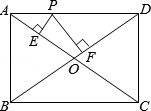As shown in the figure, the diagonals AC and BD of rectangle ABCD intersect at point O. Point P is a moving point on side AD. From point P, perpendicular PE is drawn to AC at point E, and perpendicular PF is drawn to BD at point F. If AB = 3 and BC = 4, the value of PE + PF is (). To solve for PE + PF, we first recognize that rectangle ABCD has sides of length 3 and 4, giving an area of 12. By splitting the rectangle into four right triangles via the diagonals AC and BD, each triangle has an area of 3. Now, consider triangles AOP and DOP within triangle AOD. The areas of these two triangles add up to the area of triangle AOD. Since OA and OD are half of the rectangle's diagonals, they are both 2.5 units long. Knowing the area of triangle AOD is 3, we can set up the equation: 0.5 * OA * (PE) + 0.5 * OD * (PF) = 3, substituting OA and OD with 2.5 leads to 0.5 * 2.5 * (PE + PF) = 3. Finally, solving for (PE + PF) gives us 2.4. Thus, the precise length of the sum of the perpendiculars from P to both diagonals is 2.4 units. 